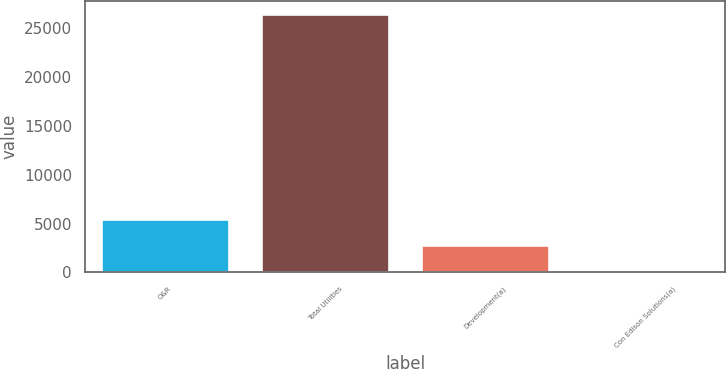<chart> <loc_0><loc_0><loc_500><loc_500><bar_chart><fcel>O&R<fcel>Total Utilities<fcel>Development(a)<fcel>Con Edison Solutions(a)<nl><fcel>5447.4<fcel>26421<fcel>2825.7<fcel>204<nl></chart> 